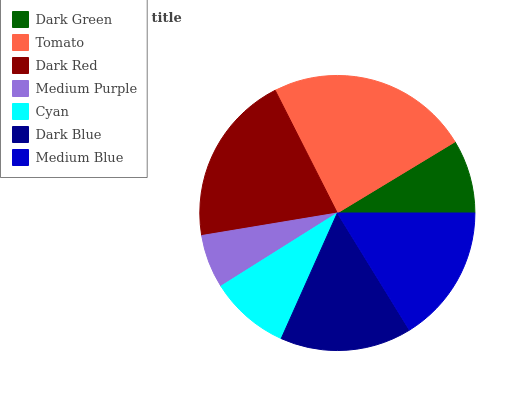Is Medium Purple the minimum?
Answer yes or no. Yes. Is Tomato the maximum?
Answer yes or no. Yes. Is Dark Red the minimum?
Answer yes or no. No. Is Dark Red the maximum?
Answer yes or no. No. Is Tomato greater than Dark Red?
Answer yes or no. Yes. Is Dark Red less than Tomato?
Answer yes or no. Yes. Is Dark Red greater than Tomato?
Answer yes or no. No. Is Tomato less than Dark Red?
Answer yes or no. No. Is Dark Blue the high median?
Answer yes or no. Yes. Is Dark Blue the low median?
Answer yes or no. Yes. Is Medium Blue the high median?
Answer yes or no. No. Is Dark Red the low median?
Answer yes or no. No. 